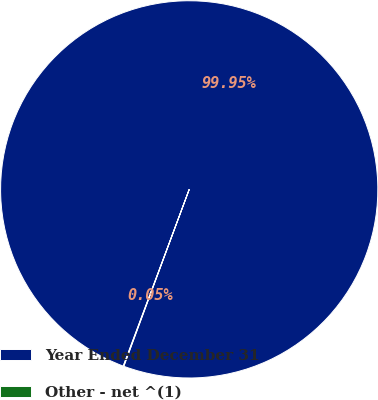Convert chart to OTSL. <chart><loc_0><loc_0><loc_500><loc_500><pie_chart><fcel>Year Ended December 31<fcel>Other - net ^(1)<nl><fcel>99.95%<fcel>0.05%<nl></chart> 